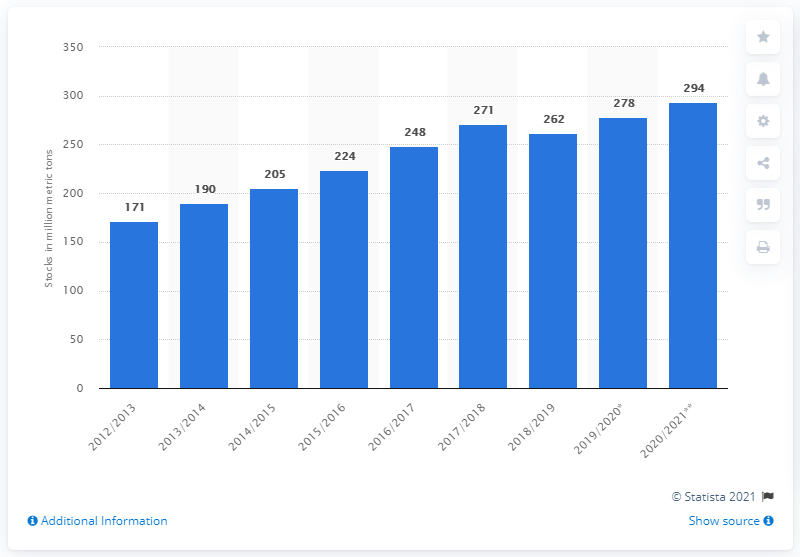Give some essential details in this illustration. According to estimates, the global stock of wheat is projected to increase to X by the 2019/2020 season. In crop year 2015/2016, the global stock of wheat was approximately 224 million metric tons. 